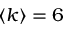Convert formula to latex. <formula><loc_0><loc_0><loc_500><loc_500>\left < k \right > = 6</formula> 